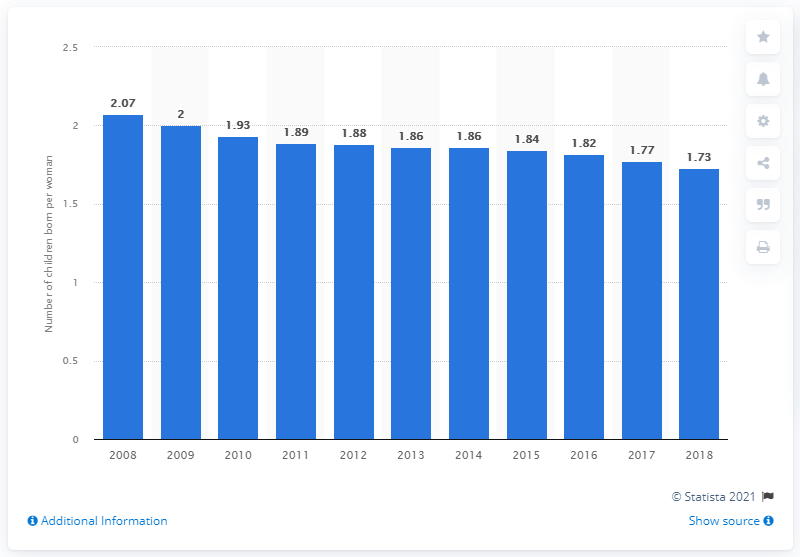List a handful of essential elements in this visual. The fertility rate in the United States in 2018 was 1.73. 